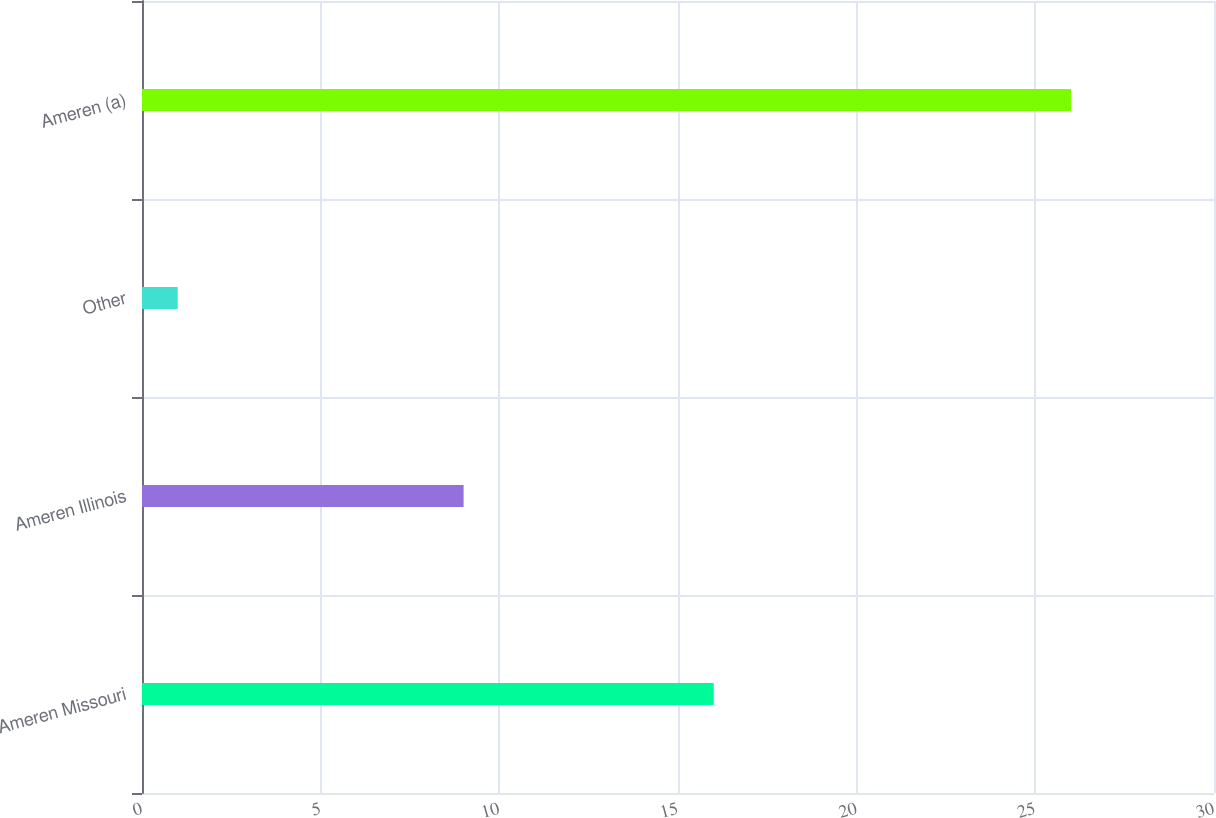<chart> <loc_0><loc_0><loc_500><loc_500><bar_chart><fcel>Ameren Missouri<fcel>Ameren Illinois<fcel>Other<fcel>Ameren (a)<nl><fcel>16<fcel>9<fcel>1<fcel>26<nl></chart> 